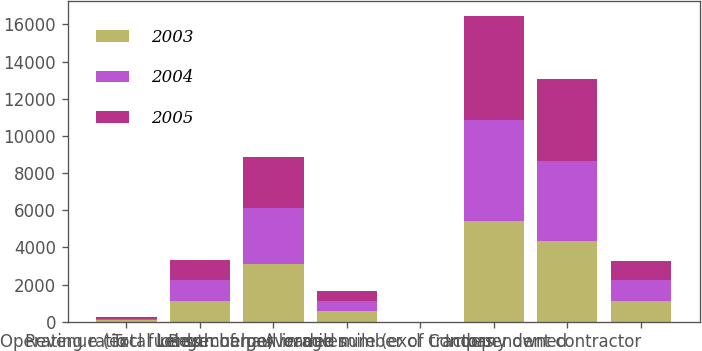Convert chart to OTSL. <chart><loc_0><loc_0><loc_500><loc_500><stacked_bar_chart><ecel><fcel>Operating ratio<fcel>Total loads<fcel>Revenue (excl fuel surcharge)<fcel>Length of haul in miles<fcel>Revenue per loaded mile (excl<fcel>Average number of tractors<fcel>Company owned<fcel>Independent contractor<nl><fcel>2003<fcel>88.4<fcel>1113<fcel>3128<fcel>558<fcel>1.75<fcel>5430<fcel>4368<fcel>1142<nl><fcel>2004<fcel>88.9<fcel>1113<fcel>2999<fcel>540<fcel>1.66<fcel>5420<fcel>4280<fcel>1113<nl><fcel>2005<fcel>94.1<fcel>1113<fcel>2739<fcel>535<fcel>1.53<fcel>5592<fcel>4429<fcel>994<nl></chart> 